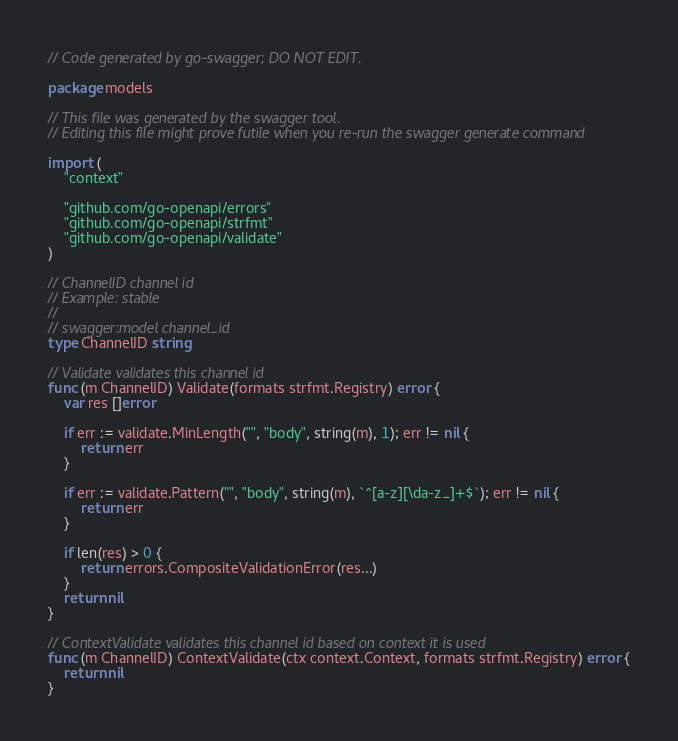<code> <loc_0><loc_0><loc_500><loc_500><_Go_>// Code generated by go-swagger; DO NOT EDIT.

package models

// This file was generated by the swagger tool.
// Editing this file might prove futile when you re-run the swagger generate command

import (
	"context"

	"github.com/go-openapi/errors"
	"github.com/go-openapi/strfmt"
	"github.com/go-openapi/validate"
)

// ChannelID channel id
// Example: stable
//
// swagger:model channel_id
type ChannelID string

// Validate validates this channel id
func (m ChannelID) Validate(formats strfmt.Registry) error {
	var res []error

	if err := validate.MinLength("", "body", string(m), 1); err != nil {
		return err
	}

	if err := validate.Pattern("", "body", string(m), `^[a-z][\da-z_]+$`); err != nil {
		return err
	}

	if len(res) > 0 {
		return errors.CompositeValidationError(res...)
	}
	return nil
}

// ContextValidate validates this channel id based on context it is used
func (m ChannelID) ContextValidate(ctx context.Context, formats strfmt.Registry) error {
	return nil
}
</code> 